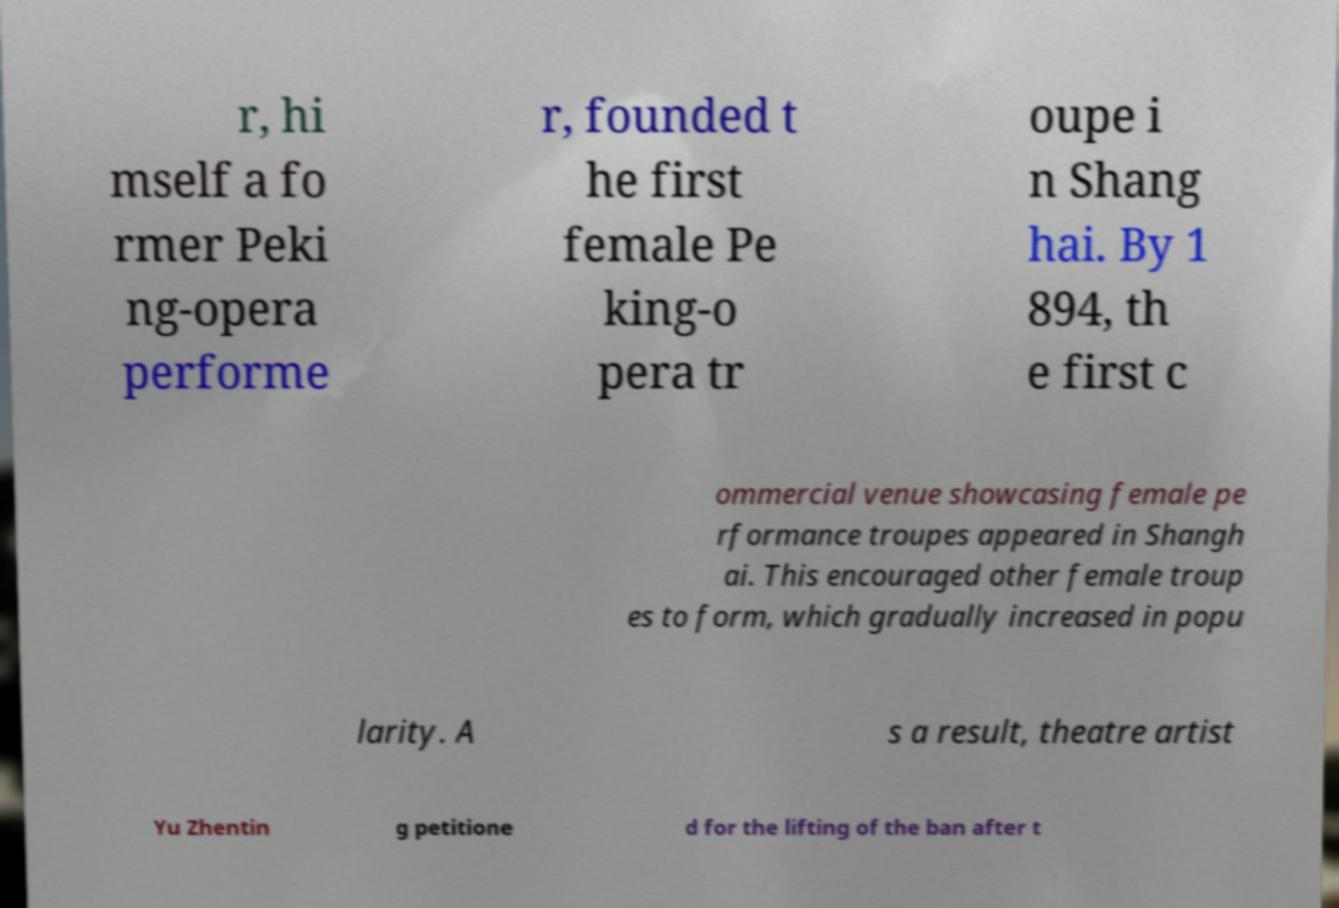Could you assist in decoding the text presented in this image and type it out clearly? r, hi mself a fo rmer Peki ng-opera performe r, founded t he first female Pe king-o pera tr oupe i n Shang hai. By 1 894, th e first c ommercial venue showcasing female pe rformance troupes appeared in Shangh ai. This encouraged other female troup es to form, which gradually increased in popu larity. A s a result, theatre artist Yu Zhentin g petitione d for the lifting of the ban after t 